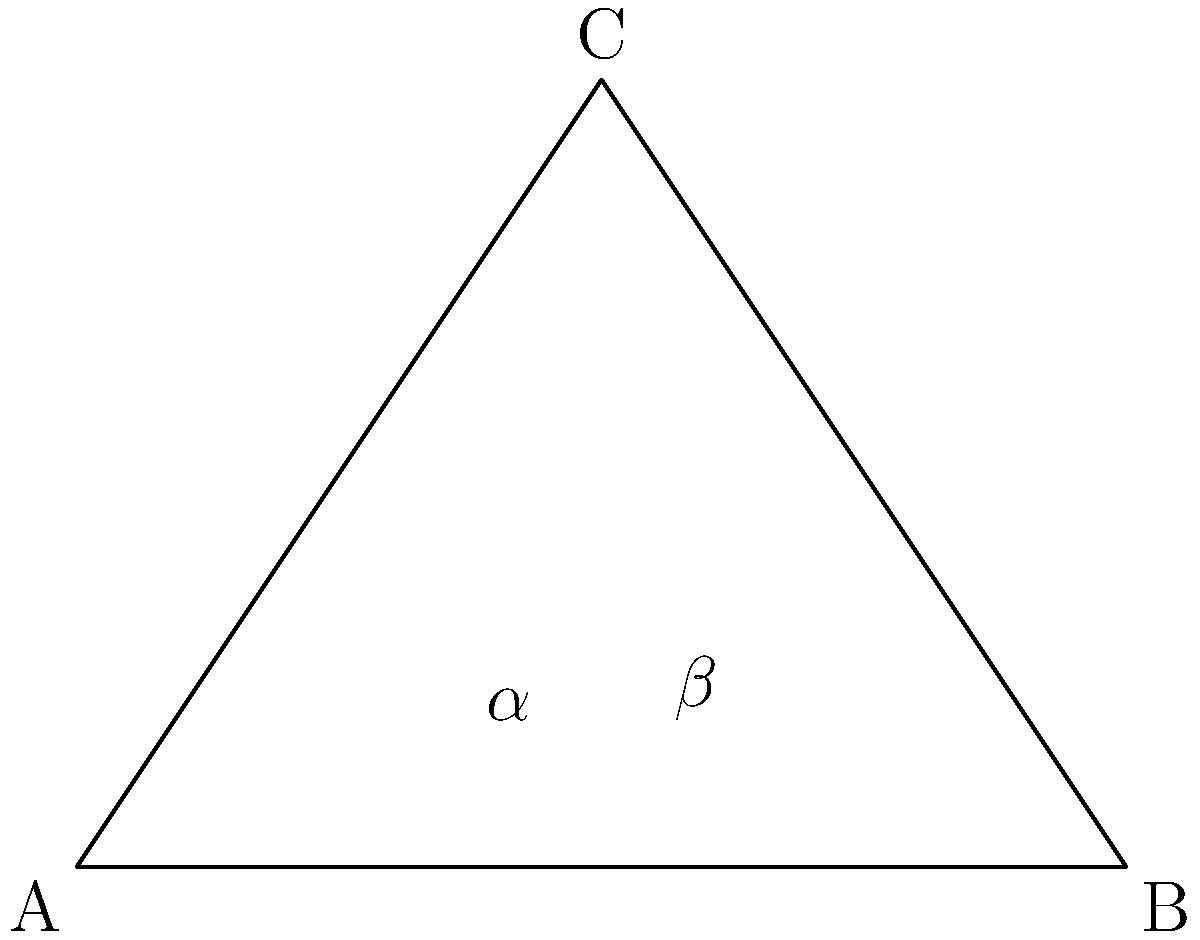In a study of nerve pathways, two intersecting pain signals are represented by lines AC and BC in the diagram. Given that the angle at C is 60°, and the lengths of AC and BC are equal, determine the measure of angle $\alpha$ where the nerve pathways intersect. Let's approach this step-by-step:

1) First, we notice that triangle ABC is isosceles, as AC = BC.

2) In an isosceles triangle, the base angles are equal. This means that $\alpha = \beta$.

3) We know that the sum of angles in a triangle is always 180°. So:

   $\alpha + \beta + 60° = 180°$

4) Since $\alpha = \beta$, we can replace $\beta$ with $\alpha$:

   $\alpha + \alpha + 60° = 180°$
   $2\alpha + 60° = 180°$

5) Subtract 60° from both sides:

   $2\alpha = 120°$

6) Divide both sides by 2:

   $\alpha = 60°$

Therefore, the measure of angle $\alpha$ is 60°.
Answer: 60° 